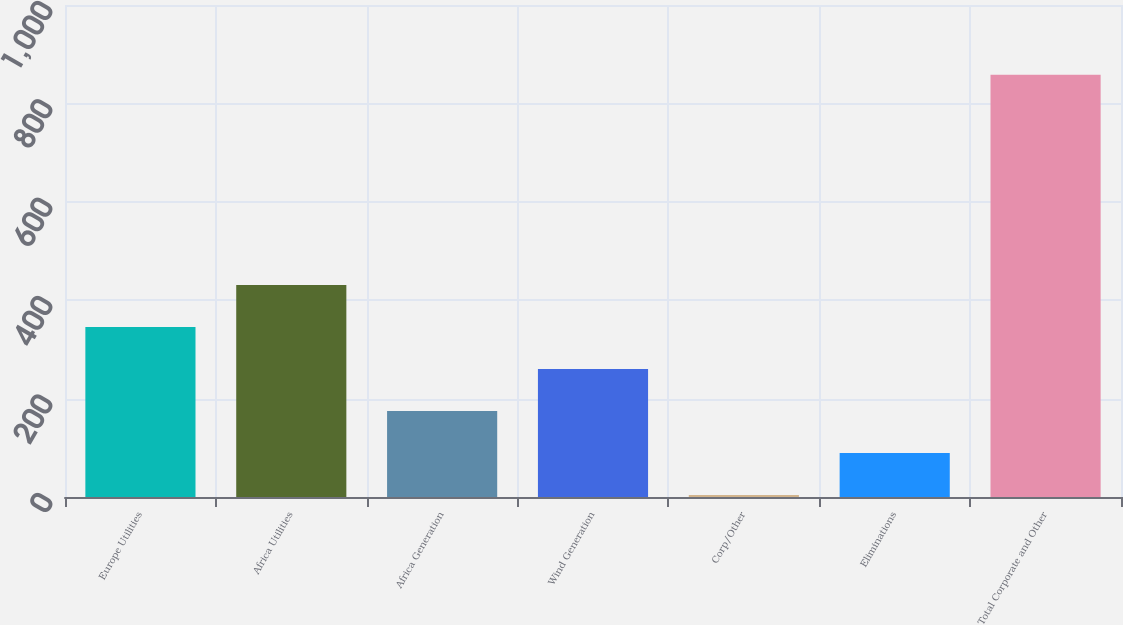Convert chart. <chart><loc_0><loc_0><loc_500><loc_500><bar_chart><fcel>Europe Utilities<fcel>Africa Utilities<fcel>Africa Generation<fcel>Wind Generation<fcel>Corp/Other<fcel>Eliminations<fcel>Total Corporate and Other<nl><fcel>345.6<fcel>431<fcel>174.8<fcel>260.2<fcel>4<fcel>89.4<fcel>858<nl></chart> 